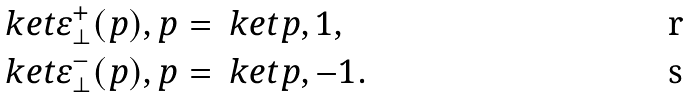Convert formula to latex. <formula><loc_0><loc_0><loc_500><loc_500>& \ k e t { \varepsilon _ { \perp } ^ { + } ( p ) , p } = \ k e t { p , 1 } , \\ & \ k e t { \varepsilon _ { \perp } ^ { - } ( p ) , p } = \ k e t { p , - 1 } .</formula> 